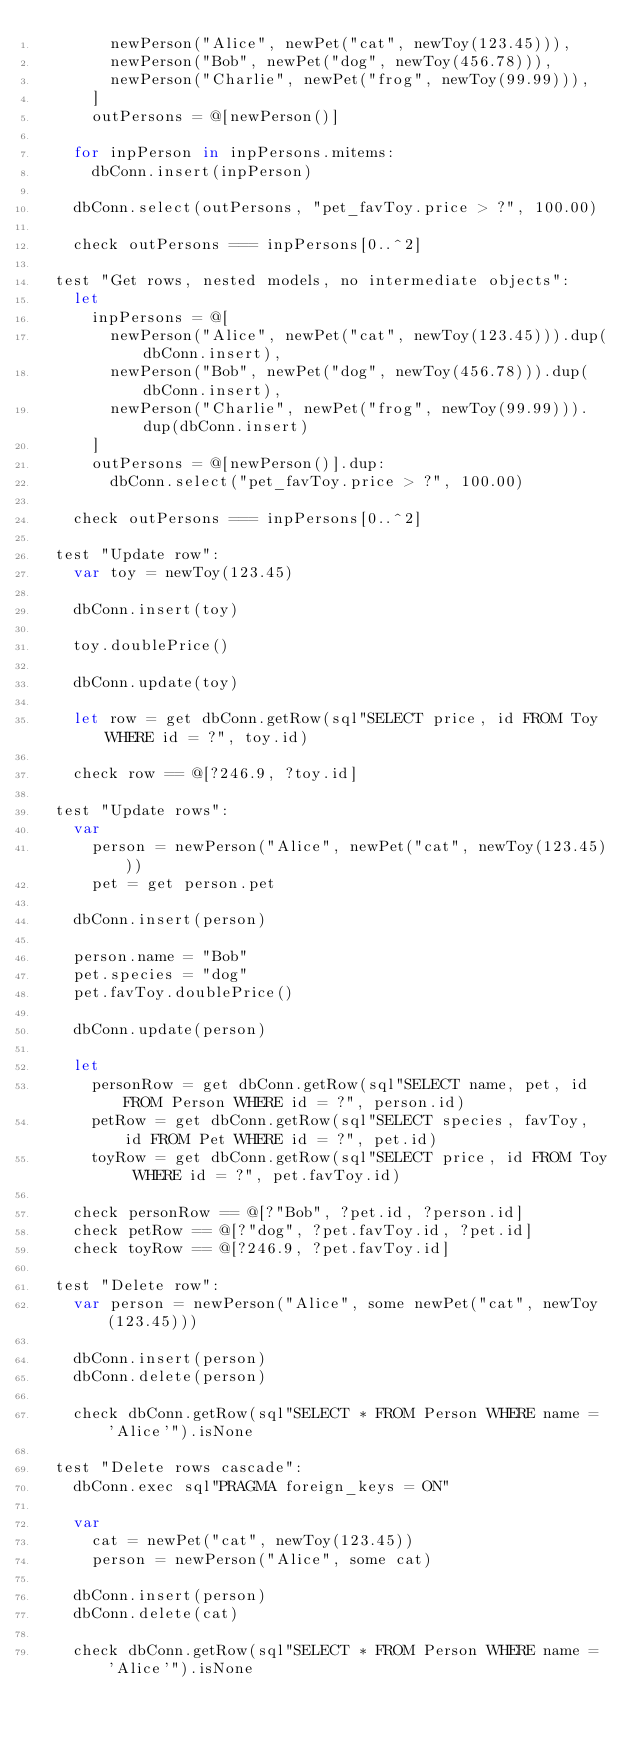<code> <loc_0><loc_0><loc_500><loc_500><_Nim_>        newPerson("Alice", newPet("cat", newToy(123.45))),
        newPerson("Bob", newPet("dog", newToy(456.78))),
        newPerson("Charlie", newPet("frog", newToy(99.99))),
      ]
      outPersons = @[newPerson()]

    for inpPerson in inpPersons.mitems:
      dbConn.insert(inpPerson)

    dbConn.select(outPersons, "pet_favToy.price > ?", 100.00)

    check outPersons === inpPersons[0..^2]

  test "Get rows, nested models, no intermediate objects":
    let
      inpPersons = @[
        newPerson("Alice", newPet("cat", newToy(123.45))).dup(dbConn.insert),
        newPerson("Bob", newPet("dog", newToy(456.78))).dup(dbConn.insert),
        newPerson("Charlie", newPet("frog", newToy(99.99))).dup(dbConn.insert)
      ]
      outPersons = @[newPerson()].dup:
        dbConn.select("pet_favToy.price > ?", 100.00)

    check outPersons === inpPersons[0..^2]

  test "Update row":
    var toy = newToy(123.45)

    dbConn.insert(toy)

    toy.doublePrice()

    dbConn.update(toy)

    let row = get dbConn.getRow(sql"SELECT price, id FROM Toy WHERE id = ?", toy.id)

    check row == @[?246.9, ?toy.id]

  test "Update rows":
    var
      person = newPerson("Alice", newPet("cat", newToy(123.45)))
      pet = get person.pet

    dbConn.insert(person)

    person.name = "Bob"
    pet.species = "dog"
    pet.favToy.doublePrice()

    dbConn.update(person)

    let
      personRow = get dbConn.getRow(sql"SELECT name, pet, id FROM Person WHERE id = ?", person.id)
      petRow = get dbConn.getRow(sql"SELECT species, favToy, id FROM Pet WHERE id = ?", pet.id)
      toyRow = get dbConn.getRow(sql"SELECT price, id FROM Toy WHERE id = ?", pet.favToy.id)

    check personRow == @[?"Bob", ?pet.id, ?person.id]
    check petRow == @[?"dog", ?pet.favToy.id, ?pet.id]
    check toyRow == @[?246.9, ?pet.favToy.id]

  test "Delete row":
    var person = newPerson("Alice", some newPet("cat", newToy(123.45)))

    dbConn.insert(person)
    dbConn.delete(person)

    check dbConn.getRow(sql"SELECT * FROM Person WHERE name = 'Alice'").isNone

  test "Delete rows cascade":
    dbConn.exec sql"PRAGMA foreign_keys = ON"

    var
      cat = newPet("cat", newToy(123.45))
      person = newPerson("Alice", some cat)

    dbConn.insert(person)
    dbConn.delete(cat)

    check dbConn.getRow(sql"SELECT * FROM Person WHERE name = 'Alice'").isNone
</code> 